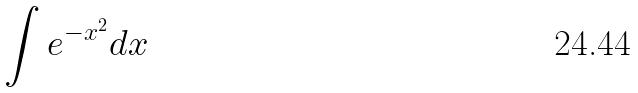Convert formula to latex. <formula><loc_0><loc_0><loc_500><loc_500>\int e ^ { - x ^ { 2 } } d x</formula> 